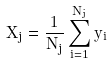<formula> <loc_0><loc_0><loc_500><loc_500>X _ { j } = \frac { 1 } { N _ { j } } \sum _ { i = 1 } ^ { N _ { j } } y _ { i }</formula> 